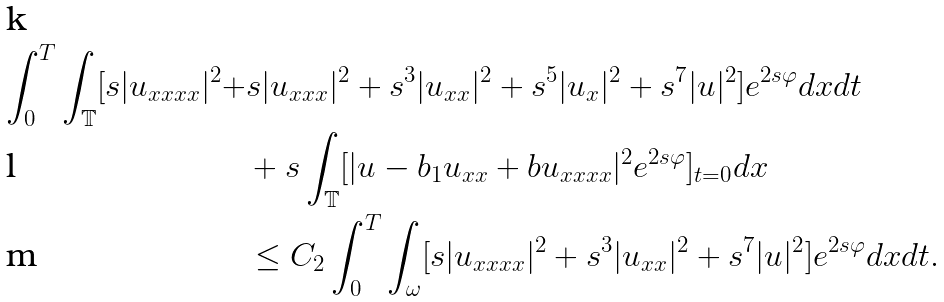Convert formula to latex. <formula><loc_0><loc_0><loc_500><loc_500>\int _ { 0 } ^ { T } \int _ { \mathbb { T } } [ s | u _ { x x x x } | ^ { 2 } + & s | u _ { x x x } | ^ { 2 } + s ^ { 3 } | u _ { x x } | ^ { 2 } + s ^ { 5 } | u _ { x } | ^ { 2 } + s ^ { 7 } | u | ^ { 2 } ] e ^ { 2 s \varphi } d x d t \\ & + s \int _ { \mathbb { T } } [ | u - b _ { 1 } u _ { x x } + b u _ { x x x x } | ^ { 2 } e ^ { 2 s \varphi } ] _ { t = 0 } d x \\ & \leq C _ { 2 } \int _ { 0 } ^ { T } \int _ { \omega } [ s | u _ { x x x x } | ^ { 2 } + s ^ { 3 } | u _ { x x } | ^ { 2 } + s ^ { 7 } | u | ^ { 2 } ] e ^ { 2 s \varphi } d x d t .</formula> 